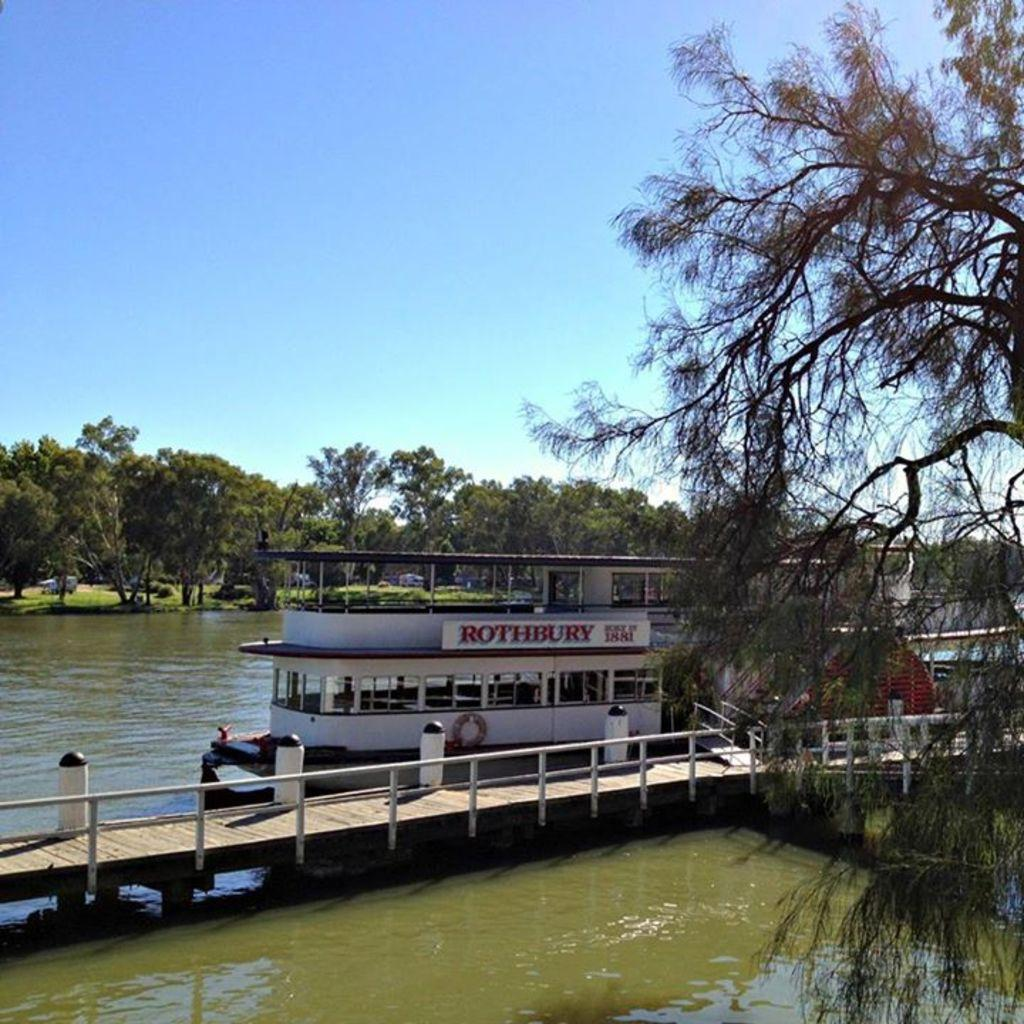What type of structure is present in the image? There is a boat house in the image. How is the boat house positioned in relation to the water? The boat house is floating on the water surface. What other structures can be seen in the image? There is a bridge beside the boat house. What type of natural environment surrounds the water surface? There are plenty of trees around the water surface. What type of stone is used to create the eye of the boat house in the image? There is no eye present on the boat house in the image, so it is not possible to determine the type of stone used. 